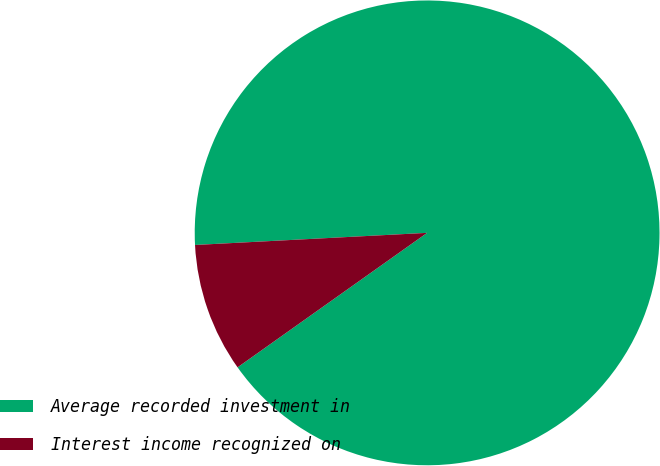Convert chart. <chart><loc_0><loc_0><loc_500><loc_500><pie_chart><fcel>Average recorded investment in<fcel>Interest income recognized on<nl><fcel>91.01%<fcel>8.99%<nl></chart> 